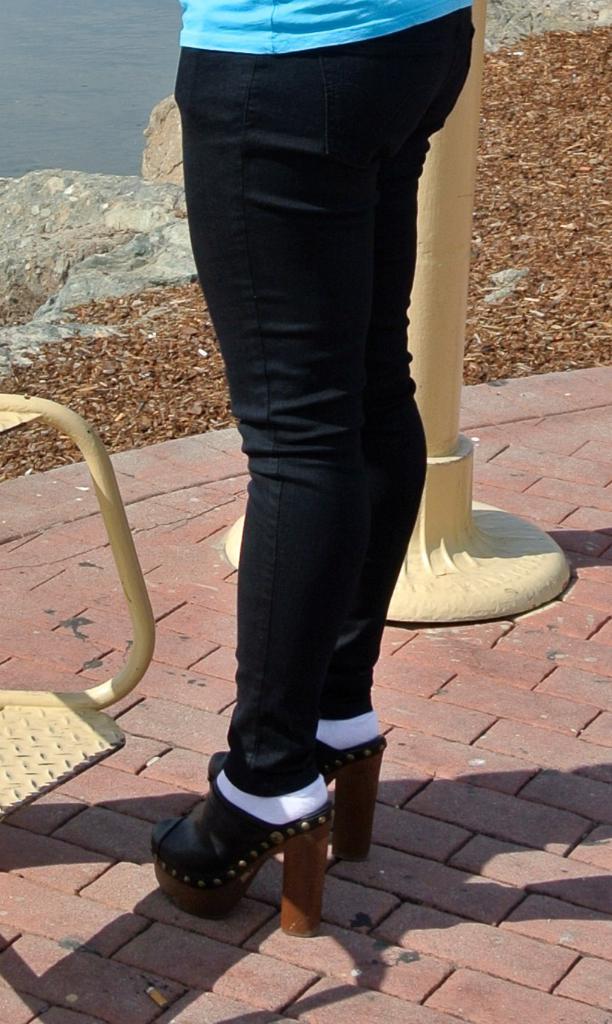Describe this image in one or two sentences. In this image I can see a woman wearing blue and black colored dress is standing on the ground and I can see a metal pole which is cream in color and few leaves on the ground. To the top left of the image I can see the water. 